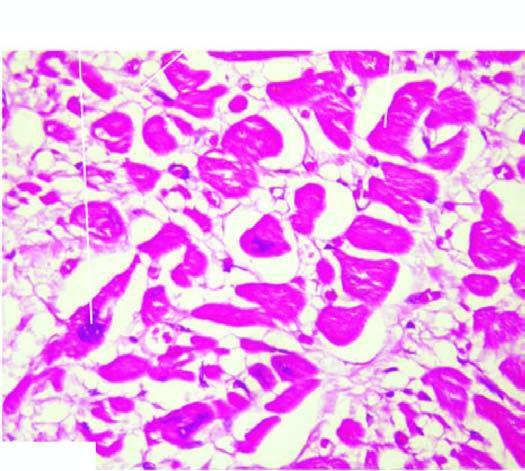re individual myocardial fibres thick with prominent vesicular nuclei?
Answer the question using a single word or phrase. Yes 